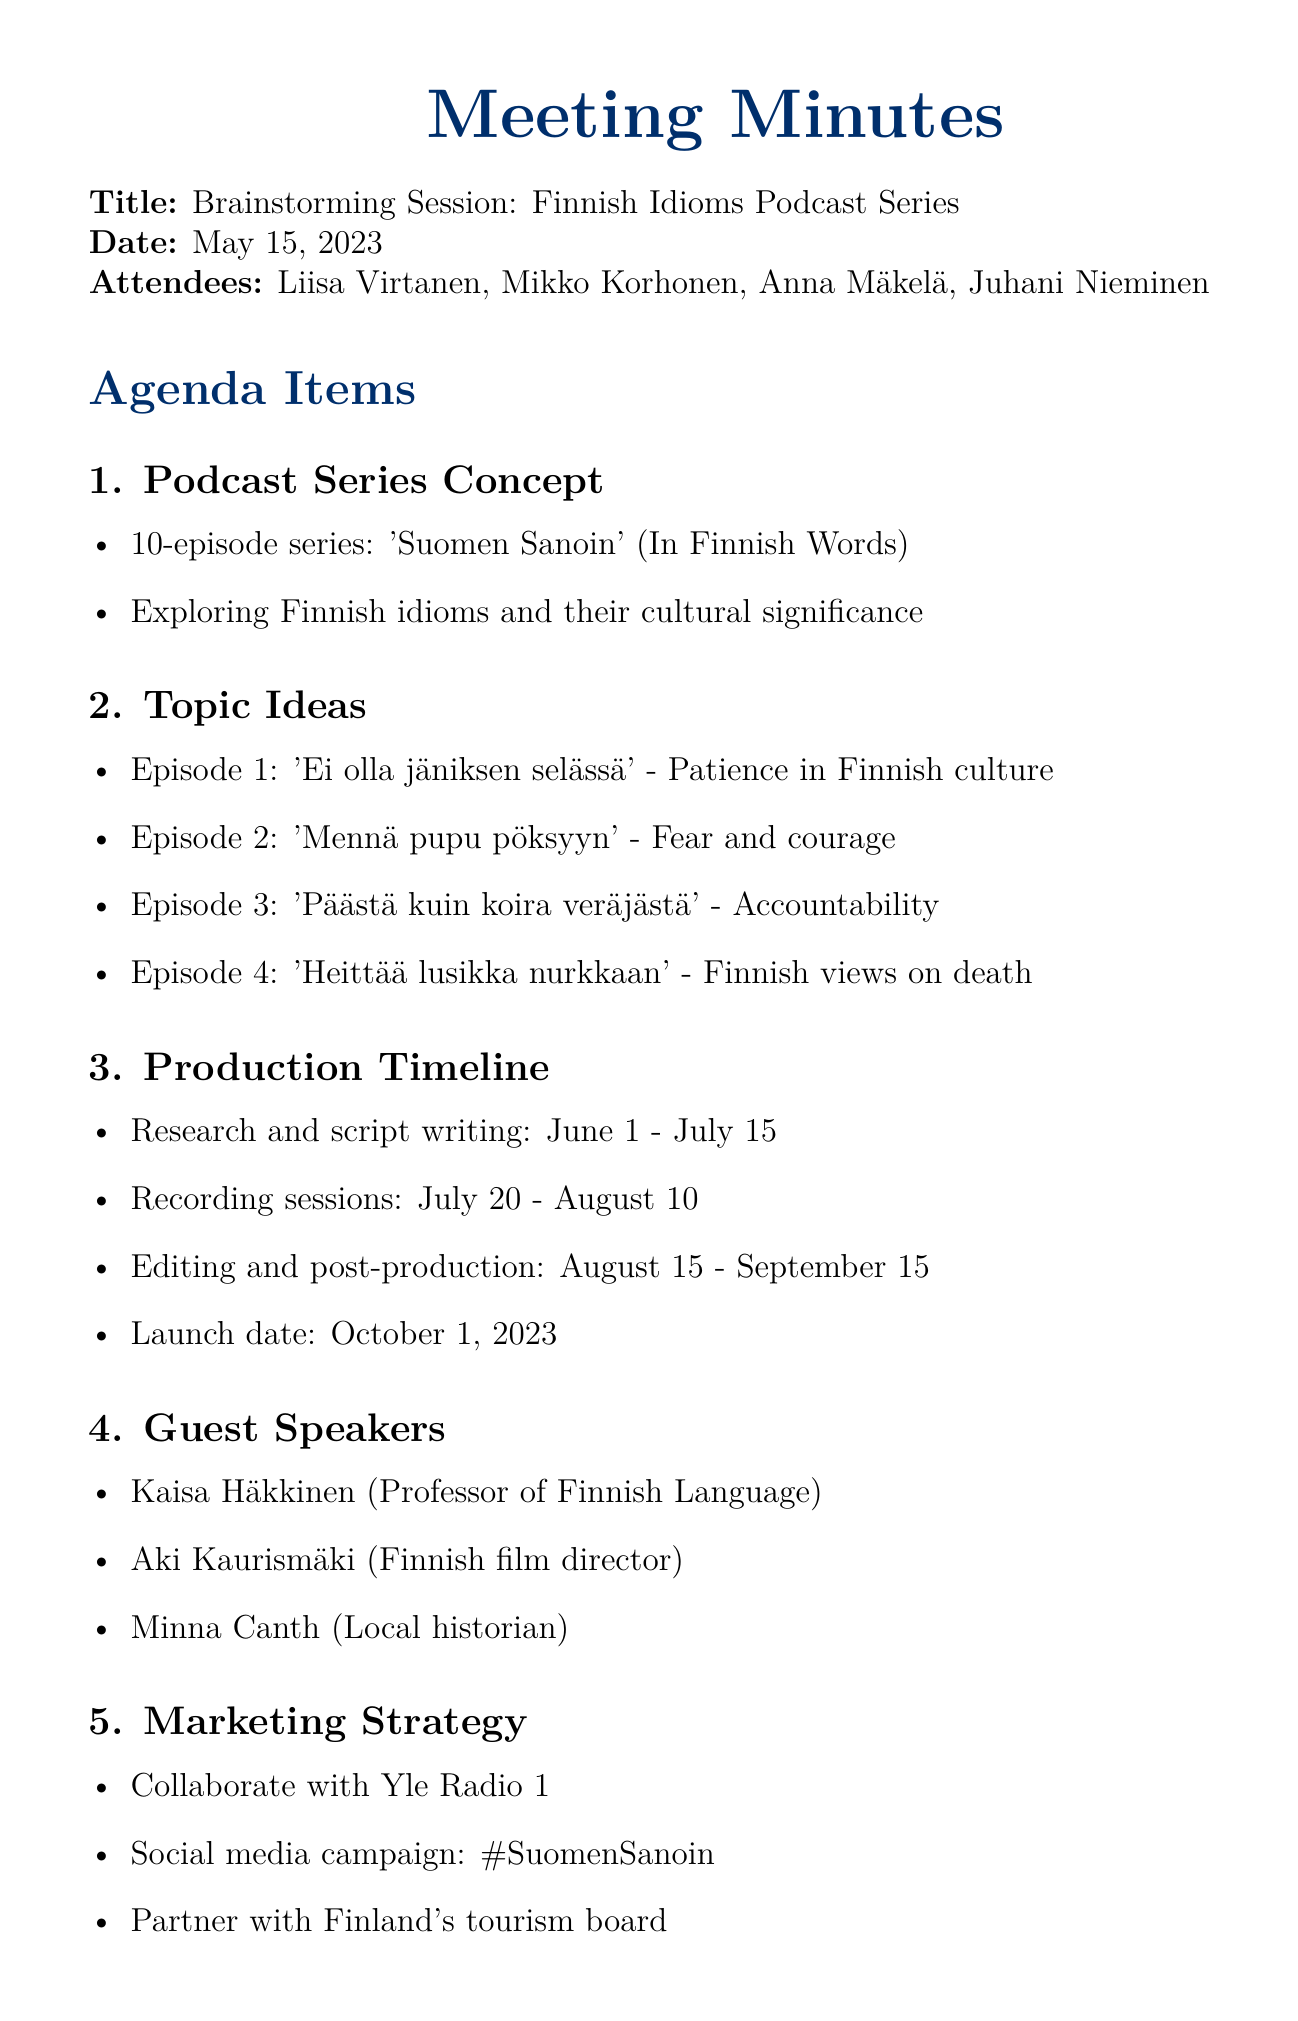What is the title of the podcast series? The title of the podcast series is mentioned in the concept section of the document.
Answer: Suomen Sanoin When is the launch date of the podcast series? The launch date is specified in the production timeline section.
Answer: October 1, 2023 Who is the sound engineer listed in the attendees? The attendees section provides the names and roles of everyone present at the meeting.
Answer: Juhani Nieminen How many episodes will the podcast series have? This information is found in the podcast series concept section.
Answer: 10 Which idiom is related to accountability in the topic ideas? The specific idiom addressing accountability can be found in the list of proposed episodes.
Answer: Päästä kuin koira veräjästä What is the estimated production cost for the podcast series? The budget considerations section outlines the estimated production cost.
Answer: €15,000 Which guest speaker is a local historian? The guest speakers section lists the individuals who will potentially participate in specific episodes.
Answer: Minna Canth What is the first action item assigned to Liisa? The action items part specifies individual responsibilities related to the project.
Answer: Finalize episode topics and reach out to potential guest speakers What date is the next meeting scheduled for? The document concludes with the next meeting date clearly stated.
Answer: May 29, 2023 